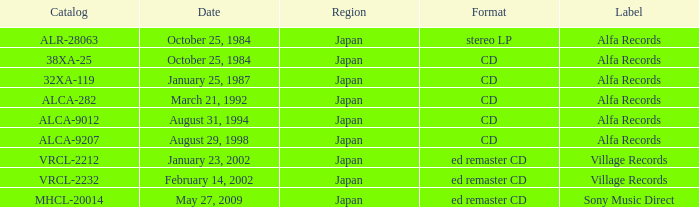What was the region of the release from May 27, 2009? Japan. 